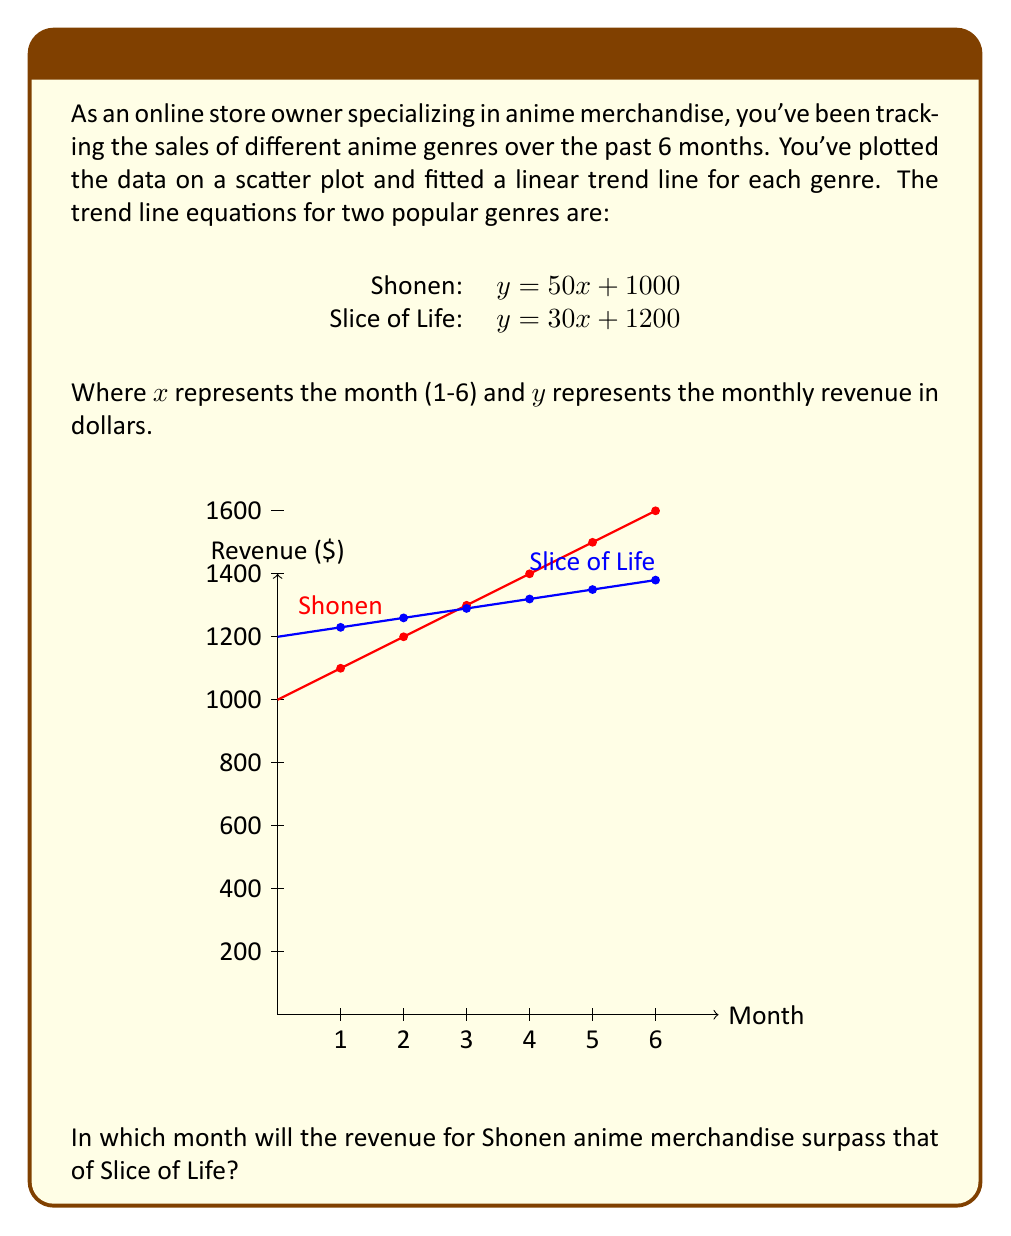Show me your answer to this math problem. To find when the Shonen revenue will surpass Slice of Life, we need to set the two equations equal to each other and solve for x:

1. Set the equations equal:
   $50x + 1000 = 30x + 1200$

2. Subtract 30x from both sides:
   $20x + 1000 = 1200$

3. Subtract 1000 from both sides:
   $20x = 200$

4. Divide both sides by 20:
   $x = 10$

5. Interpret the result:
   The lines intersect when $x = 10$, which corresponds to the 10th month.

6. Check if this matches our 6-month data:
   Since $x = 10$ is beyond our 6-month period, we need to compare the values at month 6:

   Shonen at month 6: $50(6) + 1000 = 1300$
   Slice of Life at month 6: $30(6) + 1200 = 1380$

7. Conclusion:
   At month 6, Slice of Life still has higher revenue. Shonen will surpass it in month 10, which is beyond our current data.
Answer: Month 10 